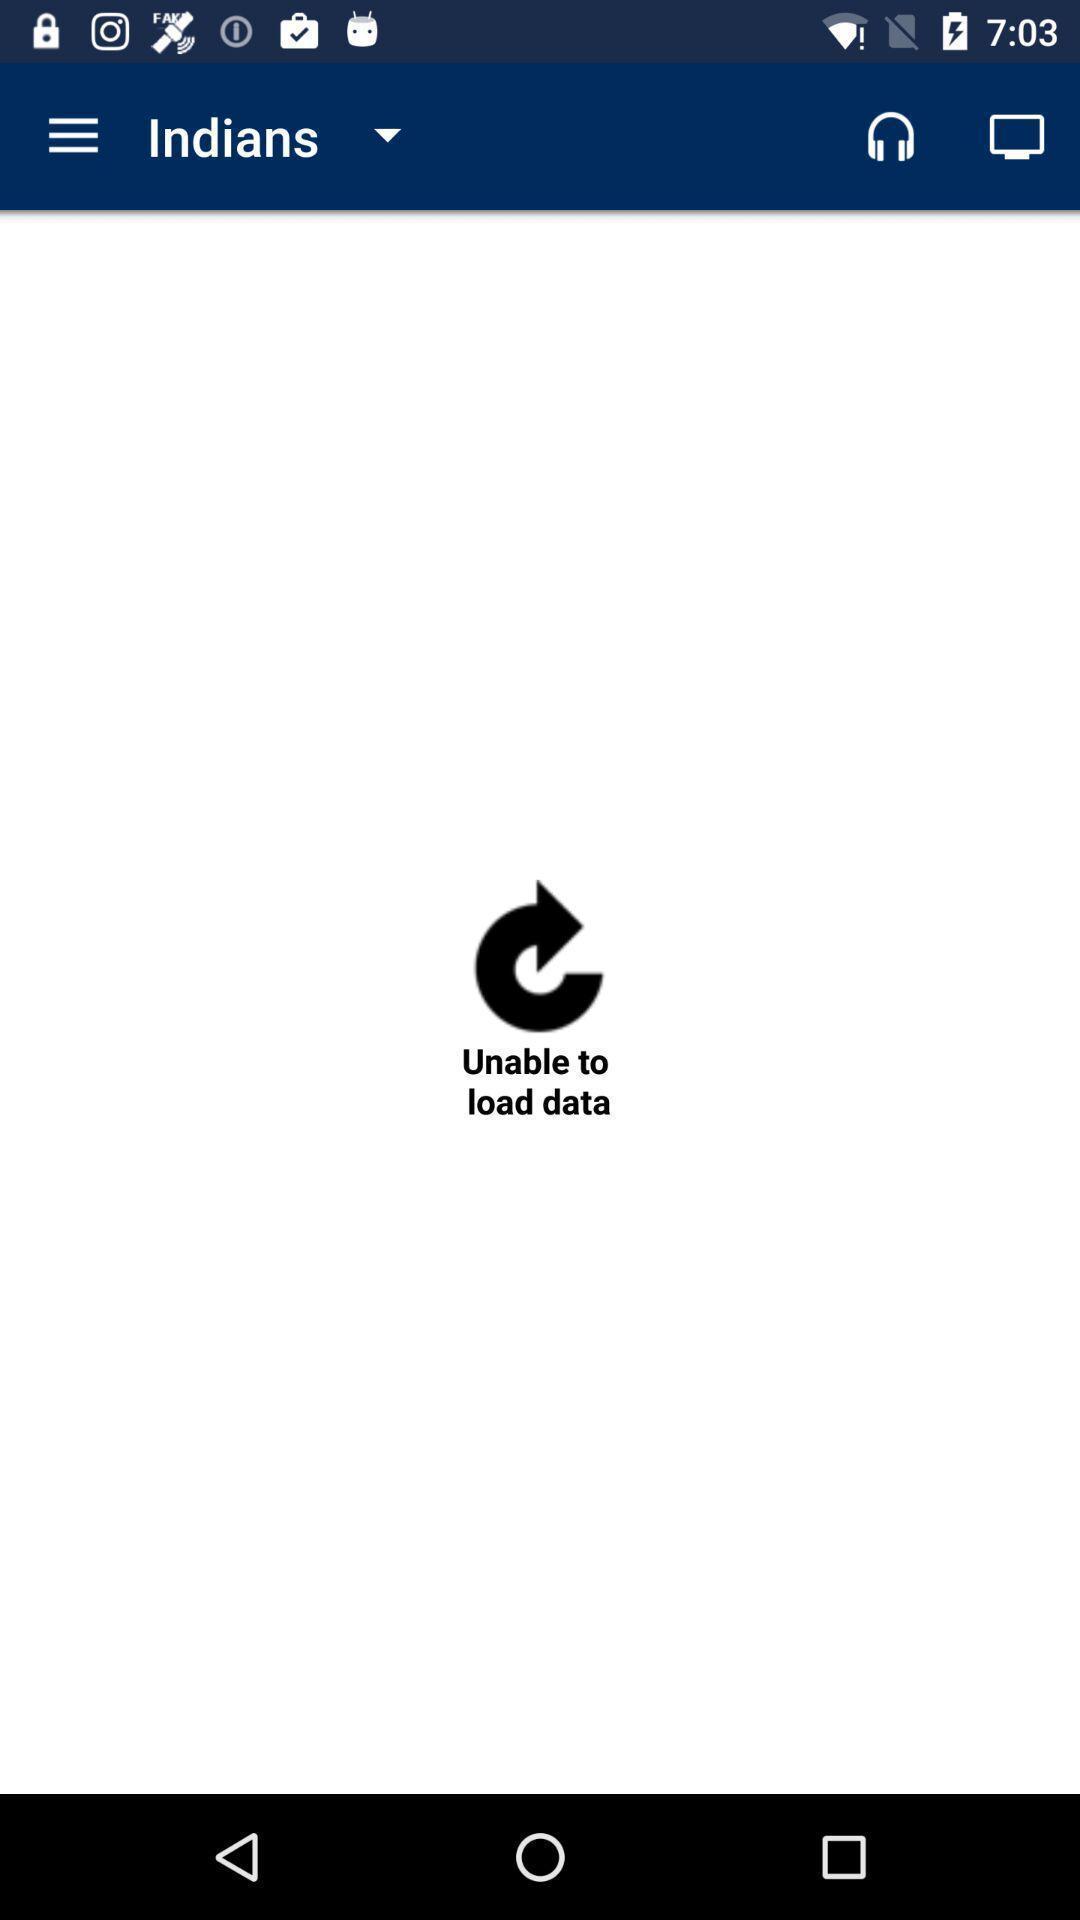Describe the content in this image. Unable to load data in indians. 